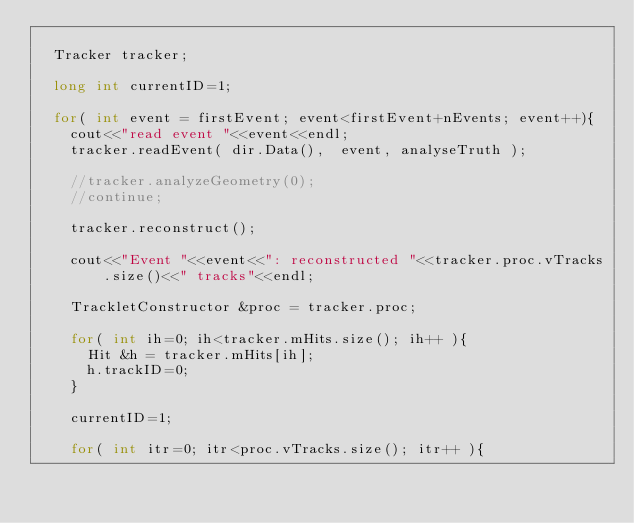Convert code to text. <code><loc_0><loc_0><loc_500><loc_500><_C++_>  
  Tracker tracker;
  
  long int currentID=1;

  for( int event = firstEvent; event<firstEvent+nEvents; event++){    
    cout<<"read event "<<event<<endl;
    tracker.readEvent( dir.Data(),  event, analyseTruth );
    
    //tracker.analyzeGeometry(0);    
    //continue;

    tracker.reconstruct();

    cout<<"Event "<<event<<": reconstructed "<<tracker.proc.vTracks.size()<<" tracks"<<endl;

    TrackletConstructor &proc = tracker.proc;

    for( int ih=0; ih<tracker.mHits.size(); ih++ ){
      Hit &h = tracker.mHits[ih];
      h.trackID=0;
    }

    currentID=1;

    for( int itr=0; itr<proc.vTracks.size(); itr++ ){</code> 